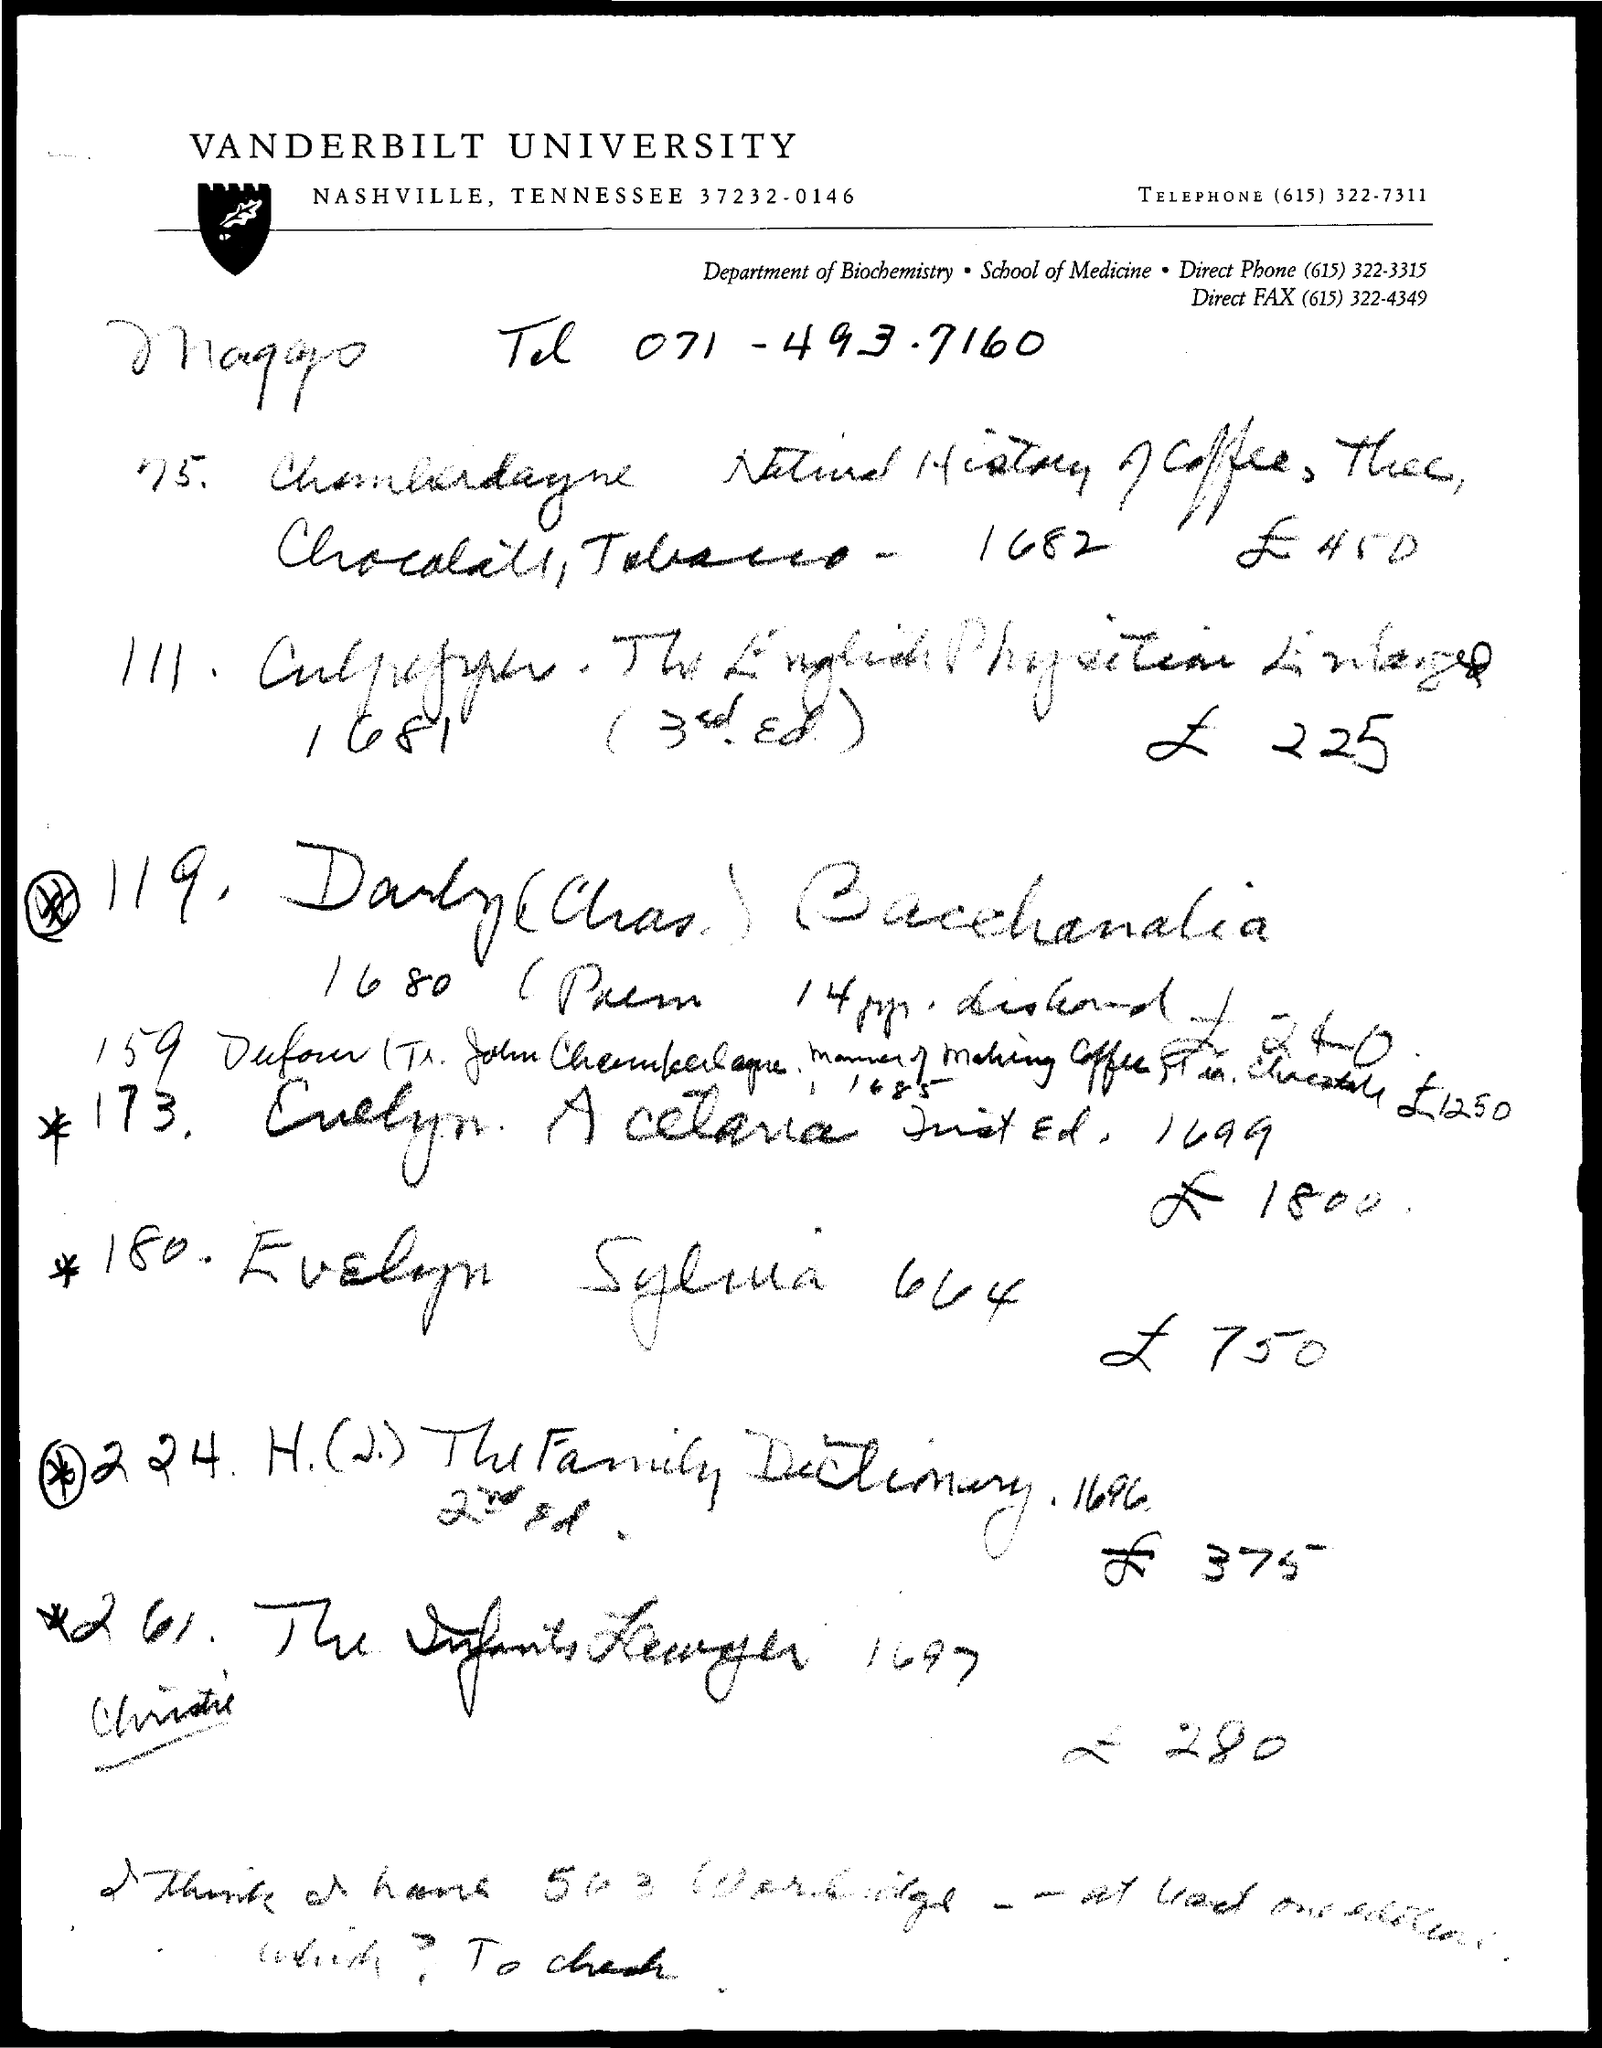What is the title of the document?
Your answer should be very brief. Vanderbilt university. What is the Fax number?
Offer a terse response. (615) 322-4349. What is the name of the department?
Your response must be concise. Department of biochemistry. 